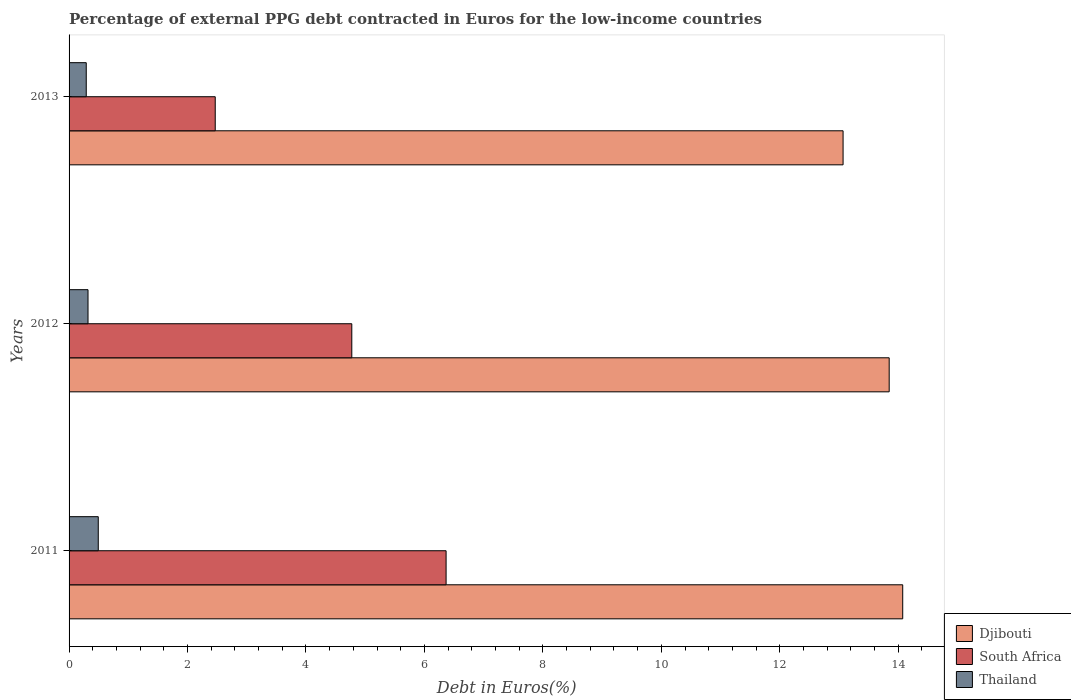Are the number of bars per tick equal to the number of legend labels?
Provide a succinct answer. Yes. What is the label of the 3rd group of bars from the top?
Offer a very short reply. 2011. In how many cases, is the number of bars for a given year not equal to the number of legend labels?
Your answer should be compact. 0. What is the percentage of external PPG debt contracted in Euros in Thailand in 2013?
Provide a short and direct response. 0.29. Across all years, what is the maximum percentage of external PPG debt contracted in Euros in Thailand?
Make the answer very short. 0.49. Across all years, what is the minimum percentage of external PPG debt contracted in Euros in South Africa?
Provide a succinct answer. 2.47. In which year was the percentage of external PPG debt contracted in Euros in Thailand maximum?
Keep it short and to the point. 2011. What is the total percentage of external PPG debt contracted in Euros in Thailand in the graph?
Offer a very short reply. 1.1. What is the difference between the percentage of external PPG debt contracted in Euros in Thailand in 2011 and that in 2012?
Give a very brief answer. 0.17. What is the difference between the percentage of external PPG debt contracted in Euros in Djibouti in 2011 and the percentage of external PPG debt contracted in Euros in South Africa in 2013?
Provide a short and direct response. 11.61. What is the average percentage of external PPG debt contracted in Euros in Thailand per year?
Offer a terse response. 0.37. In the year 2011, what is the difference between the percentage of external PPG debt contracted in Euros in South Africa and percentage of external PPG debt contracted in Euros in Thailand?
Offer a terse response. 5.87. In how many years, is the percentage of external PPG debt contracted in Euros in Thailand greater than 8 %?
Provide a short and direct response. 0. What is the ratio of the percentage of external PPG debt contracted in Euros in Djibouti in 2011 to that in 2013?
Provide a succinct answer. 1.08. Is the percentage of external PPG debt contracted in Euros in Djibouti in 2011 less than that in 2013?
Give a very brief answer. No. What is the difference between the highest and the second highest percentage of external PPG debt contracted in Euros in Thailand?
Keep it short and to the point. 0.17. What is the difference between the highest and the lowest percentage of external PPG debt contracted in Euros in South Africa?
Provide a succinct answer. 3.9. In how many years, is the percentage of external PPG debt contracted in Euros in South Africa greater than the average percentage of external PPG debt contracted in Euros in South Africa taken over all years?
Make the answer very short. 2. Is the sum of the percentage of external PPG debt contracted in Euros in Thailand in 2012 and 2013 greater than the maximum percentage of external PPG debt contracted in Euros in Djibouti across all years?
Provide a succinct answer. No. What does the 3rd bar from the top in 2013 represents?
Make the answer very short. Djibouti. What does the 3rd bar from the bottom in 2011 represents?
Keep it short and to the point. Thailand. Is it the case that in every year, the sum of the percentage of external PPG debt contracted in Euros in South Africa and percentage of external PPG debt contracted in Euros in Djibouti is greater than the percentage of external PPG debt contracted in Euros in Thailand?
Give a very brief answer. Yes. How many bars are there?
Provide a short and direct response. 9. Are all the bars in the graph horizontal?
Provide a succinct answer. Yes. What is the difference between two consecutive major ticks on the X-axis?
Provide a succinct answer. 2. Are the values on the major ticks of X-axis written in scientific E-notation?
Ensure brevity in your answer.  No. Does the graph contain any zero values?
Give a very brief answer. No. Where does the legend appear in the graph?
Offer a very short reply. Bottom right. How many legend labels are there?
Make the answer very short. 3. What is the title of the graph?
Give a very brief answer. Percentage of external PPG debt contracted in Euros for the low-income countries. Does "Ireland" appear as one of the legend labels in the graph?
Provide a short and direct response. No. What is the label or title of the X-axis?
Keep it short and to the point. Debt in Euros(%). What is the Debt in Euros(%) of Djibouti in 2011?
Provide a succinct answer. 14.08. What is the Debt in Euros(%) of South Africa in 2011?
Offer a terse response. 6.37. What is the Debt in Euros(%) of Thailand in 2011?
Offer a terse response. 0.49. What is the Debt in Euros(%) in Djibouti in 2012?
Make the answer very short. 13.85. What is the Debt in Euros(%) of South Africa in 2012?
Offer a terse response. 4.77. What is the Debt in Euros(%) in Thailand in 2012?
Your answer should be very brief. 0.32. What is the Debt in Euros(%) in Djibouti in 2013?
Keep it short and to the point. 13.07. What is the Debt in Euros(%) in South Africa in 2013?
Keep it short and to the point. 2.47. What is the Debt in Euros(%) in Thailand in 2013?
Make the answer very short. 0.29. Across all years, what is the maximum Debt in Euros(%) in Djibouti?
Offer a very short reply. 14.08. Across all years, what is the maximum Debt in Euros(%) of South Africa?
Offer a terse response. 6.37. Across all years, what is the maximum Debt in Euros(%) of Thailand?
Keep it short and to the point. 0.49. Across all years, what is the minimum Debt in Euros(%) of Djibouti?
Ensure brevity in your answer.  13.07. Across all years, what is the minimum Debt in Euros(%) in South Africa?
Your answer should be very brief. 2.47. Across all years, what is the minimum Debt in Euros(%) of Thailand?
Offer a very short reply. 0.29. What is the total Debt in Euros(%) in Djibouti in the graph?
Give a very brief answer. 40.99. What is the total Debt in Euros(%) of South Africa in the graph?
Make the answer very short. 13.61. What is the total Debt in Euros(%) of Thailand in the graph?
Keep it short and to the point. 1.1. What is the difference between the Debt in Euros(%) of Djibouti in 2011 and that in 2012?
Provide a succinct answer. 0.23. What is the difference between the Debt in Euros(%) in South Africa in 2011 and that in 2012?
Keep it short and to the point. 1.59. What is the difference between the Debt in Euros(%) of Thailand in 2011 and that in 2012?
Your answer should be very brief. 0.17. What is the difference between the Debt in Euros(%) of South Africa in 2011 and that in 2013?
Make the answer very short. 3.9. What is the difference between the Debt in Euros(%) in Thailand in 2011 and that in 2013?
Your answer should be very brief. 0.2. What is the difference between the Debt in Euros(%) in Djibouti in 2012 and that in 2013?
Give a very brief answer. 0.78. What is the difference between the Debt in Euros(%) of South Africa in 2012 and that in 2013?
Your answer should be compact. 2.31. What is the difference between the Debt in Euros(%) of Thailand in 2012 and that in 2013?
Offer a very short reply. 0.03. What is the difference between the Debt in Euros(%) of Djibouti in 2011 and the Debt in Euros(%) of South Africa in 2012?
Give a very brief answer. 9.3. What is the difference between the Debt in Euros(%) in Djibouti in 2011 and the Debt in Euros(%) in Thailand in 2012?
Keep it short and to the point. 13.76. What is the difference between the Debt in Euros(%) of South Africa in 2011 and the Debt in Euros(%) of Thailand in 2012?
Give a very brief answer. 6.05. What is the difference between the Debt in Euros(%) of Djibouti in 2011 and the Debt in Euros(%) of South Africa in 2013?
Your answer should be compact. 11.61. What is the difference between the Debt in Euros(%) of Djibouti in 2011 and the Debt in Euros(%) of Thailand in 2013?
Your answer should be very brief. 13.79. What is the difference between the Debt in Euros(%) of South Africa in 2011 and the Debt in Euros(%) of Thailand in 2013?
Make the answer very short. 6.08. What is the difference between the Debt in Euros(%) of Djibouti in 2012 and the Debt in Euros(%) of South Africa in 2013?
Make the answer very short. 11.38. What is the difference between the Debt in Euros(%) of Djibouti in 2012 and the Debt in Euros(%) of Thailand in 2013?
Ensure brevity in your answer.  13.56. What is the difference between the Debt in Euros(%) of South Africa in 2012 and the Debt in Euros(%) of Thailand in 2013?
Keep it short and to the point. 4.48. What is the average Debt in Euros(%) in Djibouti per year?
Your response must be concise. 13.66. What is the average Debt in Euros(%) in South Africa per year?
Provide a succinct answer. 4.54. What is the average Debt in Euros(%) of Thailand per year?
Your answer should be compact. 0.37. In the year 2011, what is the difference between the Debt in Euros(%) of Djibouti and Debt in Euros(%) of South Africa?
Your answer should be very brief. 7.71. In the year 2011, what is the difference between the Debt in Euros(%) of Djibouti and Debt in Euros(%) of Thailand?
Your answer should be very brief. 13.58. In the year 2011, what is the difference between the Debt in Euros(%) in South Africa and Debt in Euros(%) in Thailand?
Your response must be concise. 5.87. In the year 2012, what is the difference between the Debt in Euros(%) in Djibouti and Debt in Euros(%) in South Africa?
Offer a terse response. 9.07. In the year 2012, what is the difference between the Debt in Euros(%) of Djibouti and Debt in Euros(%) of Thailand?
Offer a very short reply. 13.53. In the year 2012, what is the difference between the Debt in Euros(%) in South Africa and Debt in Euros(%) in Thailand?
Give a very brief answer. 4.45. In the year 2013, what is the difference between the Debt in Euros(%) in Djibouti and Debt in Euros(%) in South Africa?
Provide a succinct answer. 10.6. In the year 2013, what is the difference between the Debt in Euros(%) of Djibouti and Debt in Euros(%) of Thailand?
Your answer should be compact. 12.78. In the year 2013, what is the difference between the Debt in Euros(%) of South Africa and Debt in Euros(%) of Thailand?
Your answer should be compact. 2.18. What is the ratio of the Debt in Euros(%) in Djibouti in 2011 to that in 2012?
Offer a terse response. 1.02. What is the ratio of the Debt in Euros(%) in South Africa in 2011 to that in 2012?
Offer a terse response. 1.33. What is the ratio of the Debt in Euros(%) in Thailand in 2011 to that in 2012?
Give a very brief answer. 1.54. What is the ratio of the Debt in Euros(%) of Djibouti in 2011 to that in 2013?
Your answer should be compact. 1.08. What is the ratio of the Debt in Euros(%) of South Africa in 2011 to that in 2013?
Provide a succinct answer. 2.58. What is the ratio of the Debt in Euros(%) of Thailand in 2011 to that in 2013?
Your answer should be compact. 1.7. What is the ratio of the Debt in Euros(%) of Djibouti in 2012 to that in 2013?
Ensure brevity in your answer.  1.06. What is the ratio of the Debt in Euros(%) in South Africa in 2012 to that in 2013?
Provide a short and direct response. 1.93. What is the ratio of the Debt in Euros(%) in Thailand in 2012 to that in 2013?
Your answer should be compact. 1.1. What is the difference between the highest and the second highest Debt in Euros(%) in Djibouti?
Ensure brevity in your answer.  0.23. What is the difference between the highest and the second highest Debt in Euros(%) in South Africa?
Provide a succinct answer. 1.59. What is the difference between the highest and the second highest Debt in Euros(%) of Thailand?
Ensure brevity in your answer.  0.17. What is the difference between the highest and the lowest Debt in Euros(%) of South Africa?
Provide a succinct answer. 3.9. What is the difference between the highest and the lowest Debt in Euros(%) of Thailand?
Offer a terse response. 0.2. 